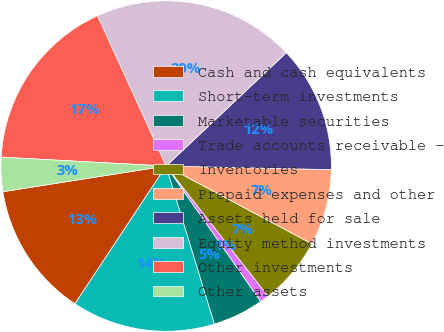<chart> <loc_0><loc_0><loc_500><loc_500><pie_chart><fcel>Cash and cash equivalents<fcel>Short-term investments<fcel>Marketable securities<fcel>Trade accounts receivable -<fcel>Inventories<fcel>Prepaid expenses and other<fcel>Assets held for sale<fcel>Equity method investments<fcel>Other investments<fcel>Other assets<nl><fcel>13.21%<fcel>14.03%<fcel>4.98%<fcel>0.87%<fcel>6.63%<fcel>7.45%<fcel>12.38%<fcel>19.79%<fcel>17.32%<fcel>3.34%<nl></chart> 